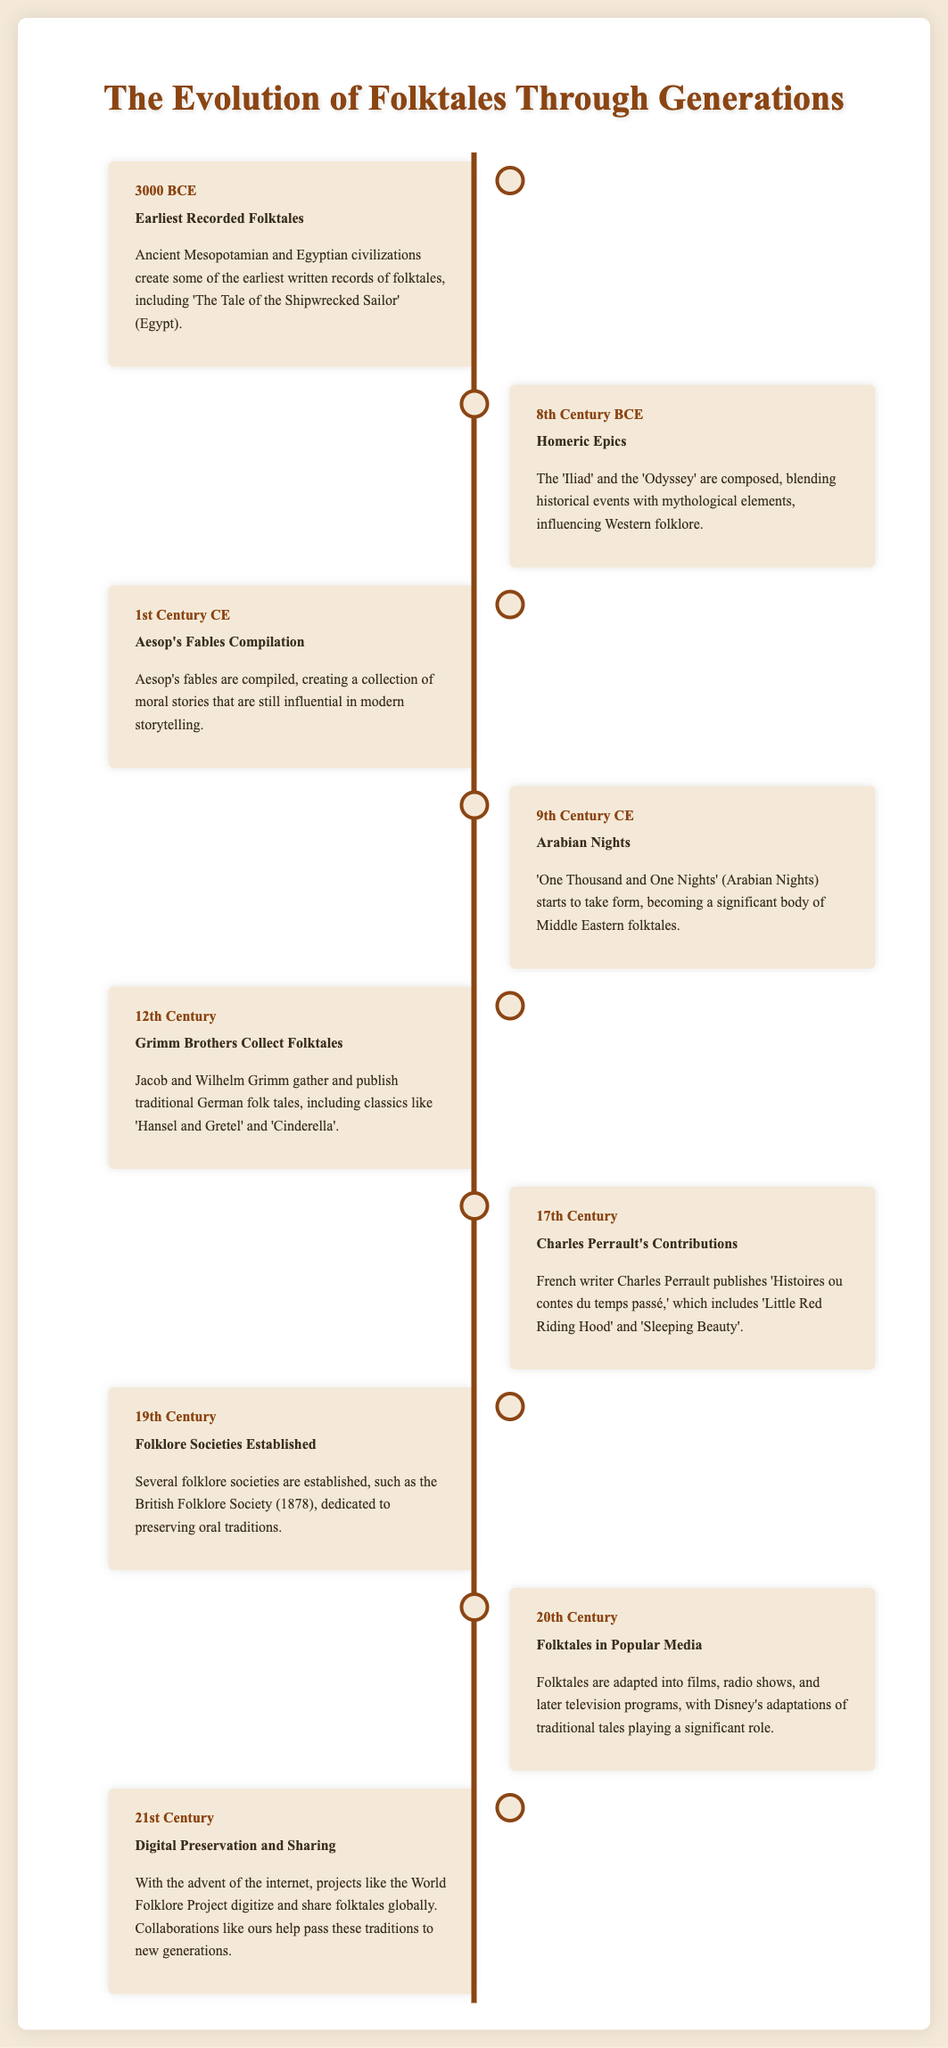What year do the earliest recorded folktales date back to? The document states that the earliest recorded folktales date back to 3000 BCE.
Answer: 3000 BCE Who published 'Histoires ou contes du temps passé'? The document mentions that Charles Perrault published 'Histoires ou contes du temps passé'.
Answer: Charles Perrault What significant collection was formed in the 1st Century CE? The document indicates that Aesop's fables were compiled in the 1st Century CE.
Answer: Aesop's Fables In which century did the Grimm Brothers collect folktales? According to the document, the Grimm Brothers collected folktales in the 12th Century.
Answer: 12th Century What was a major influence on Western folklore composed in the 8th Century BCE? The document notes that the 'Iliad' and the 'Odyssey' were major influences on Western folklore.
Answer: Iliad and Odyssey What role did Disney play in the 20th Century concerning folktales? The document states that Disney's adaptations of traditional tales played a significant role in the 20th Century.
Answer: Significant role How do collaborations in the 21st Century impact folktale preservation? The document explains that collaborations help pass these traditions to new generations.
Answer: Help pass traditions What is the focus of the folklore societies established in the 19th Century? The document mentions that folklore societies were dedicated to preserving oral traditions.
Answer: Preserving oral traditions What body of work began to take form in the 9th Century CE? The document states that 'One Thousand and One Nights' (Arabian Nights) began to take form.
Answer: One Thousand and One Nights 